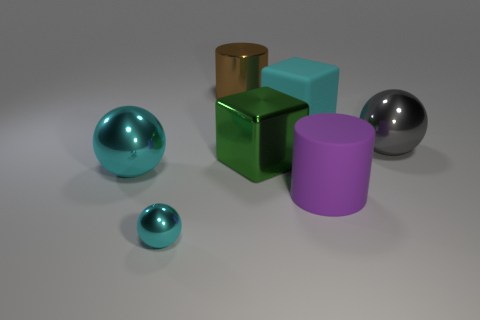Add 1 brown things. How many objects exist? 8 Subtract all blocks. How many objects are left? 5 Subtract 0 green cylinders. How many objects are left? 7 Subtract all small green metallic balls. Subtract all green objects. How many objects are left? 6 Add 4 purple cylinders. How many purple cylinders are left? 5 Add 7 brown metal cylinders. How many brown metal cylinders exist? 8 